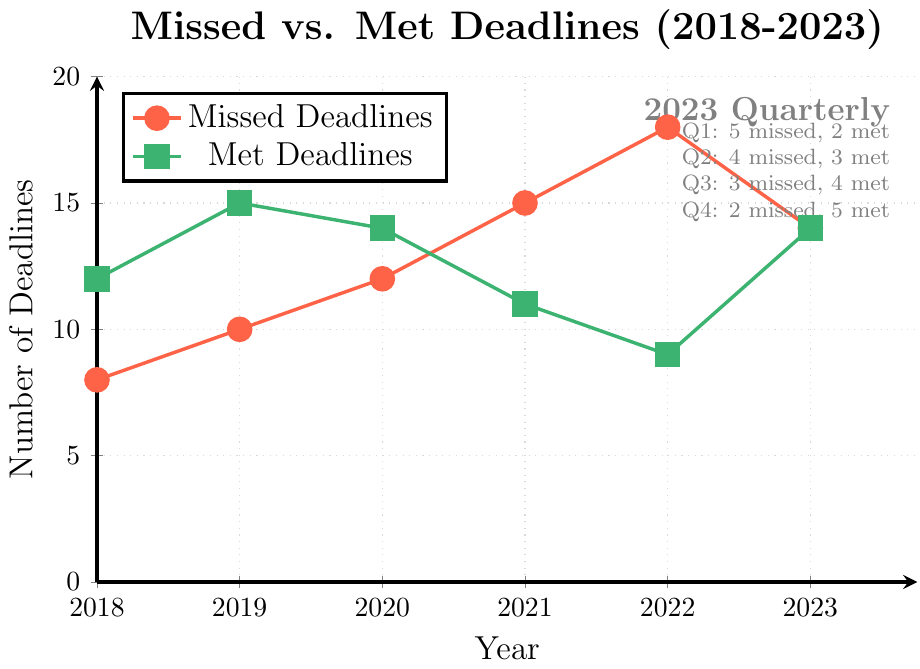Which year had the highest number of missed deadlines? The highest point on the red line, which represents missed deadlines, occurs in 2022 with 18 missed deadlines.
Answer: 2022 Compare the missed and met deadlines for the year 2020. Which category had more deadlines? In 2020, the red line (missed deadlines) is at 12, and the green line (met deadlines) is at 14.
Answer: Met deadlines What is the trend in met deadlines from 2018 to 2022? The green line decreases from 2018 (12) to 2022 (9).
Answer: Decreasing How many more missed deadlines were there in 2021 compared to 2018? Subtract the number of missed deadlines in 2018 (8) from 2021 (15), which is 15 - 8.
Answer: 7 Which quarter of 2023 had the fewest missed deadlines? The label shows the missed deadlines for each quarter of 2023. Q4 had 2 missed deadlines, the fewest.
Answer: Q4 What can be concluded from the quarterly data for 2023 regarding the deadlines met? From Q1 to Q4 in 2023, the number of deadlines met increases from 2 to 5.
Answer: Increasing trend Calculate the total number of met deadlines for the years 2018 through 2022. Sum the met deadlines from 2018 (12), 2019 (15), 2020 (14), 2021 (11), and 2022 (9), which is 12 + 15 + 14 + 11 + 9.
Answer: 61 Is there any year where the number of missed deadlines equaled the number of met deadlines? Comparing both lines, 2023 has an equal number of 14.
Answer: 2023 What is the average number of missed deadlines from 2018 to 2022? Sum the missed deadlines from 2018 (8), 2019 (10), 2020 (12), 2021 (15), and 2022 (18) and divide by 5, (8+10+12+15+18)/5.
Answer: 12.6 